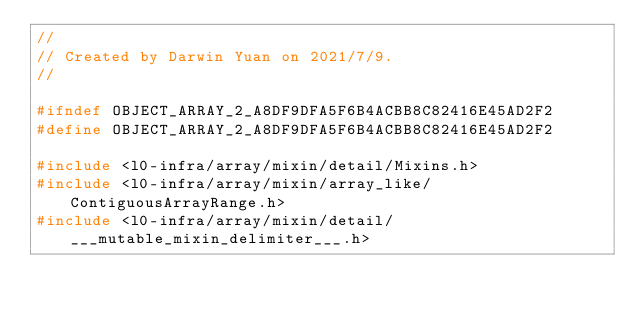<code> <loc_0><loc_0><loc_500><loc_500><_C_>//
// Created by Darwin Yuan on 2021/7/9.
//

#ifndef OBJECT_ARRAY_2_A8DF9DFA5F6B4ACBB8C82416E45AD2F2
#define OBJECT_ARRAY_2_A8DF9DFA5F6B4ACBB8C82416E45AD2F2

#include <l0-infra/array/mixin/detail/Mixins.h>
#include <l0-infra/array/mixin/array_like/ContiguousArrayRange.h>
#include <l0-infra/array/mixin/detail/___mutable_mixin_delimiter___.h></code> 